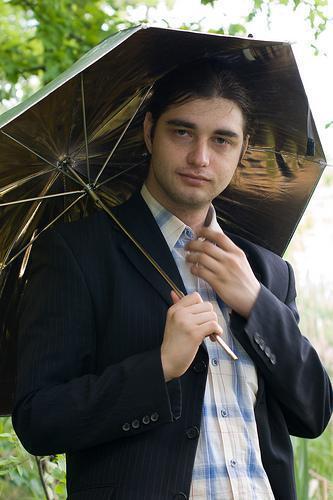How many umbrellas are there?
Give a very brief answer. 1. 